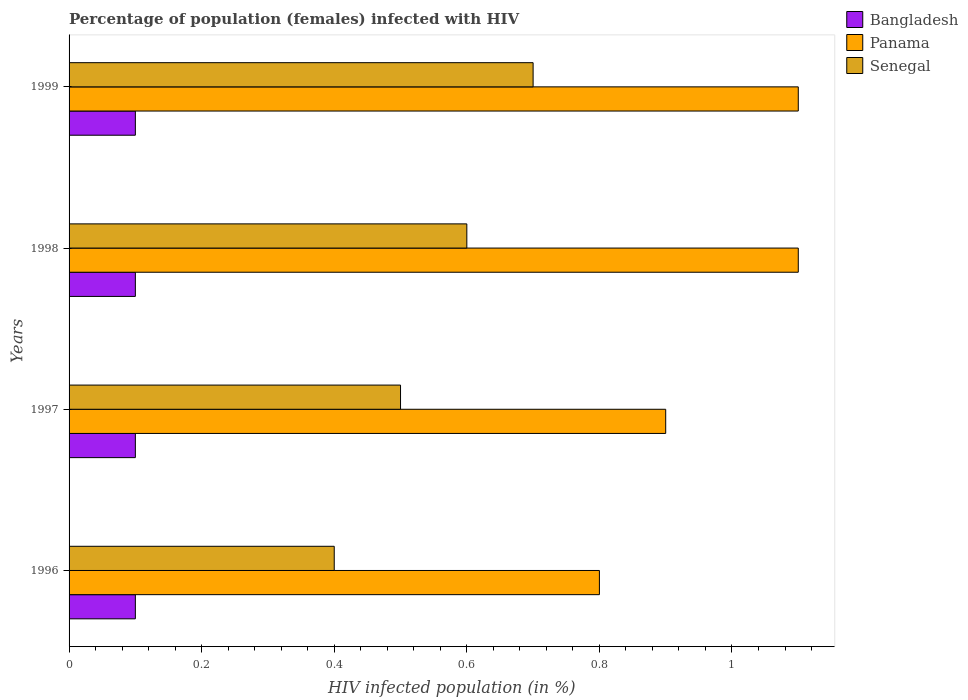Are the number of bars per tick equal to the number of legend labels?
Your answer should be very brief. Yes. In how many cases, is the number of bars for a given year not equal to the number of legend labels?
Make the answer very short. 0. What is the percentage of HIV infected female population in Panama in 1996?
Provide a short and direct response. 0.8. Across all years, what is the minimum percentage of HIV infected female population in Panama?
Keep it short and to the point. 0.8. In which year was the percentage of HIV infected female population in Bangladesh minimum?
Offer a terse response. 1996. What is the difference between the percentage of HIV infected female population in Senegal in 1996 and that in 1999?
Offer a very short reply. -0.3. What is the difference between the percentage of HIV infected female population in Bangladesh in 1997 and the percentage of HIV infected female population in Senegal in 1999?
Make the answer very short. -0.6. What is the average percentage of HIV infected female population in Senegal per year?
Your answer should be compact. 0.55. What is the difference between the highest and the second highest percentage of HIV infected female population in Senegal?
Offer a very short reply. 0.1. What does the 3rd bar from the top in 1998 represents?
Give a very brief answer. Bangladesh. What does the 2nd bar from the bottom in 1997 represents?
Your answer should be very brief. Panama. Is it the case that in every year, the sum of the percentage of HIV infected female population in Bangladesh and percentage of HIV infected female population in Senegal is greater than the percentage of HIV infected female population in Panama?
Keep it short and to the point. No. How many bars are there?
Make the answer very short. 12. What is the difference between two consecutive major ticks on the X-axis?
Your answer should be compact. 0.2. Are the values on the major ticks of X-axis written in scientific E-notation?
Your answer should be compact. No. How many legend labels are there?
Offer a terse response. 3. How are the legend labels stacked?
Ensure brevity in your answer.  Vertical. What is the title of the graph?
Your response must be concise. Percentage of population (females) infected with HIV. Does "St. Kitts and Nevis" appear as one of the legend labels in the graph?
Give a very brief answer. No. What is the label or title of the X-axis?
Offer a terse response. HIV infected population (in %). What is the label or title of the Y-axis?
Provide a succinct answer. Years. What is the HIV infected population (in %) of Bangladesh in 1996?
Make the answer very short. 0.1. What is the HIV infected population (in %) in Senegal in 1996?
Your answer should be compact. 0.4. What is the HIV infected population (in %) of Bangladesh in 1997?
Provide a succinct answer. 0.1. What is the HIV infected population (in %) of Senegal in 1997?
Your response must be concise. 0.5. What is the HIV infected population (in %) of Panama in 1998?
Your answer should be compact. 1.1. Across all years, what is the maximum HIV infected population (in %) of Panama?
Provide a short and direct response. 1.1. Across all years, what is the minimum HIV infected population (in %) in Bangladesh?
Provide a short and direct response. 0.1. Across all years, what is the minimum HIV infected population (in %) of Senegal?
Your response must be concise. 0.4. What is the difference between the HIV infected population (in %) in Bangladesh in 1996 and that in 1997?
Your answer should be very brief. 0. What is the difference between the HIV infected population (in %) in Panama in 1996 and that in 1998?
Make the answer very short. -0.3. What is the difference between the HIV infected population (in %) of Panama in 1997 and that in 1998?
Keep it short and to the point. -0.2. What is the difference between the HIV infected population (in %) of Senegal in 1997 and that in 1998?
Your response must be concise. -0.1. What is the difference between the HIV infected population (in %) of Panama in 1998 and that in 1999?
Provide a succinct answer. 0. What is the difference between the HIV infected population (in %) in Senegal in 1998 and that in 1999?
Make the answer very short. -0.1. What is the difference between the HIV infected population (in %) of Panama in 1996 and the HIV infected population (in %) of Senegal in 1997?
Your answer should be compact. 0.3. What is the difference between the HIV infected population (in %) in Bangladesh in 1996 and the HIV infected population (in %) in Panama in 1998?
Give a very brief answer. -1. What is the difference between the HIV infected population (in %) of Bangladesh in 1996 and the HIV infected population (in %) of Panama in 1999?
Give a very brief answer. -1. What is the difference between the HIV infected population (in %) of Panama in 1996 and the HIV infected population (in %) of Senegal in 1999?
Provide a short and direct response. 0.1. What is the difference between the HIV infected population (in %) of Bangladesh in 1997 and the HIV infected population (in %) of Senegal in 1998?
Offer a very short reply. -0.5. What is the difference between the HIV infected population (in %) in Bangladesh in 1997 and the HIV infected population (in %) in Panama in 1999?
Offer a terse response. -1. What is the difference between the HIV infected population (in %) in Panama in 1997 and the HIV infected population (in %) in Senegal in 1999?
Give a very brief answer. 0.2. What is the difference between the HIV infected population (in %) of Bangladesh in 1998 and the HIV infected population (in %) of Senegal in 1999?
Your answer should be compact. -0.6. What is the average HIV infected population (in %) in Bangladesh per year?
Keep it short and to the point. 0.1. What is the average HIV infected population (in %) of Senegal per year?
Make the answer very short. 0.55. In the year 1996, what is the difference between the HIV infected population (in %) in Bangladesh and HIV infected population (in %) in Panama?
Ensure brevity in your answer.  -0.7. In the year 1996, what is the difference between the HIV infected population (in %) in Bangladesh and HIV infected population (in %) in Senegal?
Give a very brief answer. -0.3. In the year 1996, what is the difference between the HIV infected population (in %) in Panama and HIV infected population (in %) in Senegal?
Your answer should be compact. 0.4. In the year 1998, what is the difference between the HIV infected population (in %) of Bangladesh and HIV infected population (in %) of Panama?
Offer a terse response. -1. In the year 1998, what is the difference between the HIV infected population (in %) in Bangladesh and HIV infected population (in %) in Senegal?
Offer a terse response. -0.5. In the year 1998, what is the difference between the HIV infected population (in %) of Panama and HIV infected population (in %) of Senegal?
Your response must be concise. 0.5. In the year 1999, what is the difference between the HIV infected population (in %) in Bangladesh and HIV infected population (in %) in Panama?
Your answer should be very brief. -1. What is the ratio of the HIV infected population (in %) of Panama in 1996 to that in 1997?
Give a very brief answer. 0.89. What is the ratio of the HIV infected population (in %) in Panama in 1996 to that in 1998?
Your response must be concise. 0.73. What is the ratio of the HIV infected population (in %) in Senegal in 1996 to that in 1998?
Ensure brevity in your answer.  0.67. What is the ratio of the HIV infected population (in %) of Panama in 1996 to that in 1999?
Your answer should be compact. 0.73. What is the ratio of the HIV infected population (in %) in Senegal in 1996 to that in 1999?
Keep it short and to the point. 0.57. What is the ratio of the HIV infected population (in %) of Panama in 1997 to that in 1998?
Ensure brevity in your answer.  0.82. What is the ratio of the HIV infected population (in %) in Senegal in 1997 to that in 1998?
Provide a succinct answer. 0.83. What is the ratio of the HIV infected population (in %) in Panama in 1997 to that in 1999?
Offer a very short reply. 0.82. What is the ratio of the HIV infected population (in %) of Senegal in 1997 to that in 1999?
Your answer should be very brief. 0.71. What is the ratio of the HIV infected population (in %) of Bangladesh in 1998 to that in 1999?
Your answer should be compact. 1. What is the ratio of the HIV infected population (in %) of Panama in 1998 to that in 1999?
Provide a succinct answer. 1. What is the ratio of the HIV infected population (in %) of Senegal in 1998 to that in 1999?
Offer a terse response. 0.86. What is the difference between the highest and the second highest HIV infected population (in %) in Panama?
Offer a very short reply. 0. What is the difference between the highest and the second highest HIV infected population (in %) of Senegal?
Keep it short and to the point. 0.1. What is the difference between the highest and the lowest HIV infected population (in %) in Bangladesh?
Keep it short and to the point. 0. What is the difference between the highest and the lowest HIV infected population (in %) in Panama?
Your answer should be very brief. 0.3. 